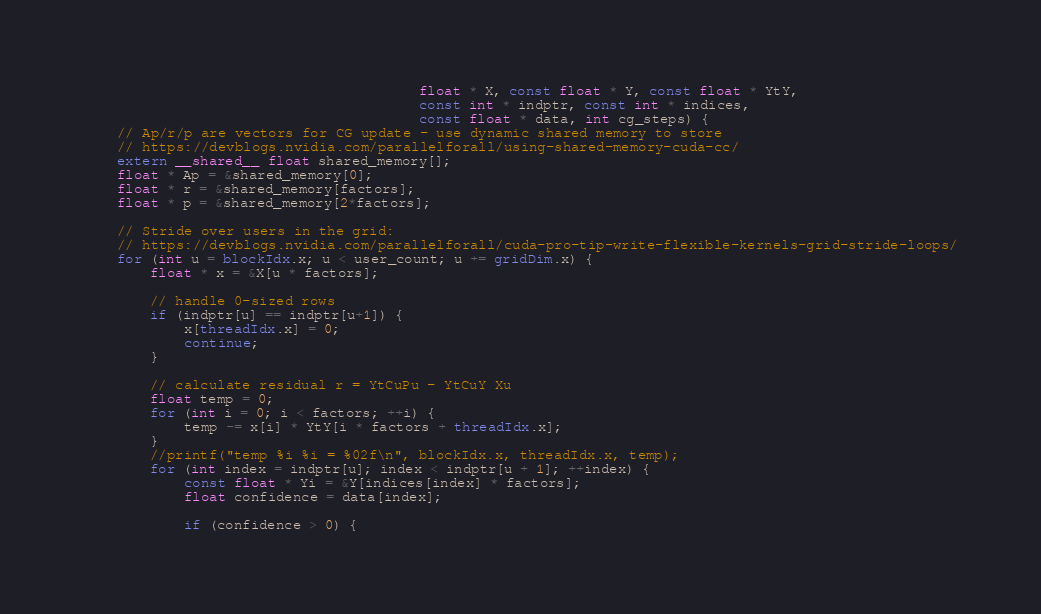<code> <loc_0><loc_0><loc_500><loc_500><_Cuda_>                                        float * X, const float * Y, const float * YtY,
                                        const int * indptr, const int * indices,
                                        const float * data, int cg_steps) {
    // Ap/r/p are vectors for CG update - use dynamic shared memory to store
    // https://devblogs.nvidia.com/parallelforall/using-shared-memory-cuda-cc/
    extern __shared__ float shared_memory[];
    float * Ap = &shared_memory[0];
    float * r = &shared_memory[factors];
    float * p = &shared_memory[2*factors];

    // Stride over users in the grid:
    // https://devblogs.nvidia.com/parallelforall/cuda-pro-tip-write-flexible-kernels-grid-stride-loops/
    for (int u = blockIdx.x; u < user_count; u += gridDim.x) {
        float * x = &X[u * factors];

        // handle 0-sized rows
        if (indptr[u] == indptr[u+1]) {
            x[threadIdx.x] = 0;
            continue;
        }

        // calculate residual r = YtCuPu - YtCuY Xu
        float temp = 0;
        for (int i = 0; i < factors; ++i) {
            temp -= x[i] * YtY[i * factors + threadIdx.x];
        }
        //printf("temp %i %i = %02f\n", blockIdx.x, threadIdx.x, temp);
        for (int index = indptr[u]; index < indptr[u + 1]; ++index) {
            const float * Yi = &Y[indices[index] * factors];
            float confidence = data[index];

            if (confidence > 0) {</code> 